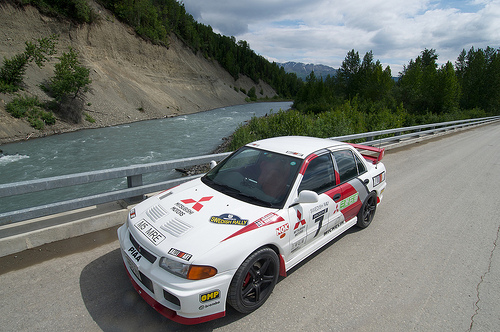<image>
Is the car on the bridge? Yes. Looking at the image, I can see the car is positioned on top of the bridge, with the bridge providing support. 